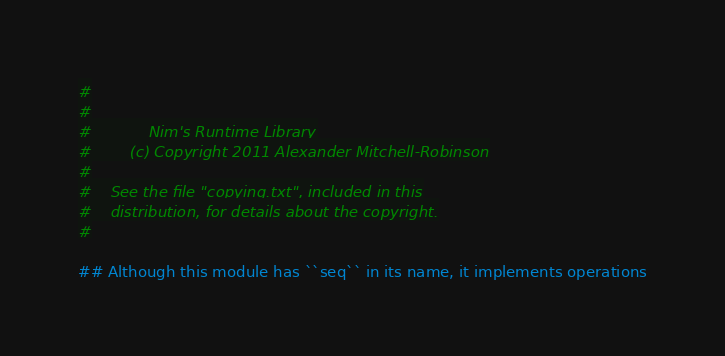<code> <loc_0><loc_0><loc_500><loc_500><_Nim_>#
#
#            Nim's Runtime Library
#        (c) Copyright 2011 Alexander Mitchell-Robinson
#
#    See the file "copying.txt", included in this
#    distribution, for details about the copyright.
#

## Although this module has ``seq`` in its name, it implements operations</code> 